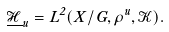Convert formula to latex. <formula><loc_0><loc_0><loc_500><loc_500>\underline { \mathcal { H } } _ { u } = L ^ { 2 } ( X / G , \rho ^ { u } , { \mathcal { K } } ) .</formula> 